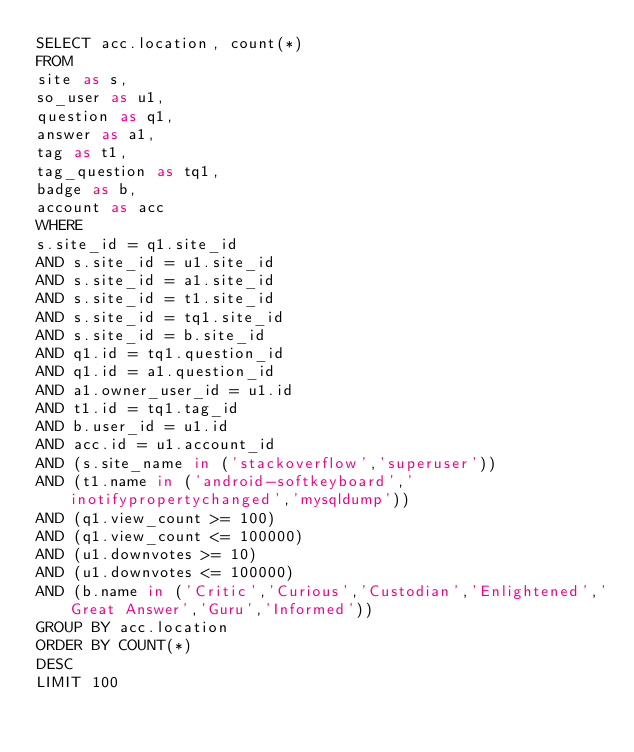<code> <loc_0><loc_0><loc_500><loc_500><_SQL_>SELECT acc.location, count(*)
FROM
site as s,
so_user as u1,
question as q1,
answer as a1,
tag as t1,
tag_question as tq1,
badge as b,
account as acc
WHERE
s.site_id = q1.site_id
AND s.site_id = u1.site_id
AND s.site_id = a1.site_id
AND s.site_id = t1.site_id
AND s.site_id = tq1.site_id
AND s.site_id = b.site_id
AND q1.id = tq1.question_id
AND q1.id = a1.question_id
AND a1.owner_user_id = u1.id
AND t1.id = tq1.tag_id
AND b.user_id = u1.id
AND acc.id = u1.account_id
AND (s.site_name in ('stackoverflow','superuser'))
AND (t1.name in ('android-softkeyboard','inotifypropertychanged','mysqldump'))
AND (q1.view_count >= 100)
AND (q1.view_count <= 100000)
AND (u1.downvotes >= 10)
AND (u1.downvotes <= 100000)
AND (b.name in ('Critic','Curious','Custodian','Enlightened','Great Answer','Guru','Informed'))
GROUP BY acc.location
ORDER BY COUNT(*)
DESC
LIMIT 100
</code> 